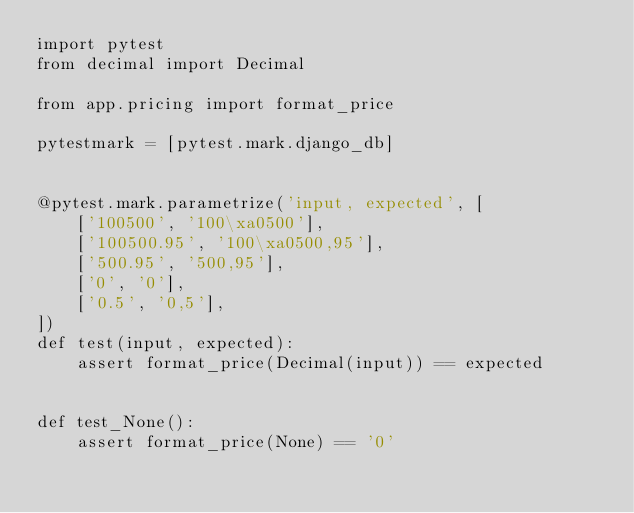<code> <loc_0><loc_0><loc_500><loc_500><_Python_>import pytest
from decimal import Decimal

from app.pricing import format_price

pytestmark = [pytest.mark.django_db]


@pytest.mark.parametrize('input, expected', [
    ['100500', '100\xa0500'],
    ['100500.95', '100\xa0500,95'],
    ['500.95', '500,95'],
    ['0', '0'],
    ['0.5', '0,5'],
])
def test(input, expected):
    assert format_price(Decimal(input)) == expected


def test_None():
    assert format_price(None) == '0'
</code> 